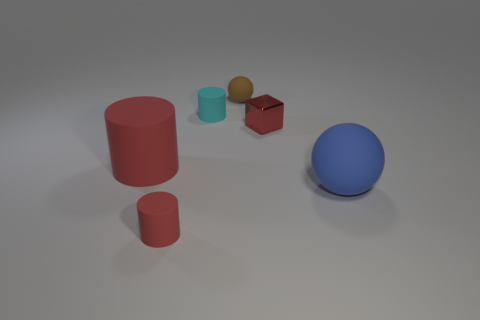How many things are tiny objects right of the tiny brown rubber object or large spheres?
Make the answer very short. 2. What is the size of the thing that is on the right side of the shiny thing?
Keep it short and to the point. Large. What material is the block?
Ensure brevity in your answer.  Metal. What is the shape of the shiny object right of the matte ball behind the big red object?
Provide a short and direct response. Cube. What number of other objects are the same shape as the blue object?
Provide a short and direct response. 1. Are there any tiny brown matte balls right of the cyan rubber cylinder?
Ensure brevity in your answer.  Yes. What color is the metallic block?
Provide a short and direct response. Red. There is a small sphere; does it have the same color as the tiny cylinder that is in front of the large red rubber cylinder?
Your response must be concise. No. Is there a blue matte thing of the same size as the cyan rubber cylinder?
Keep it short and to the point. No. What is the size of the matte object that is the same color as the large matte cylinder?
Make the answer very short. Small. 